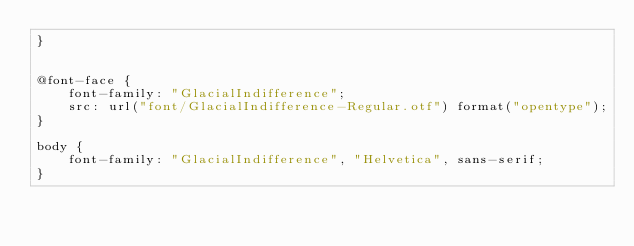Convert code to text. <code><loc_0><loc_0><loc_500><loc_500><_CSS_>}


@font-face {
    font-family: "GlacialIndifference";
    src: url("font/GlacialIndifference-Regular.otf") format("opentype");
}

body {
    font-family: "GlacialIndifference", "Helvetica", sans-serif;
}

</code> 